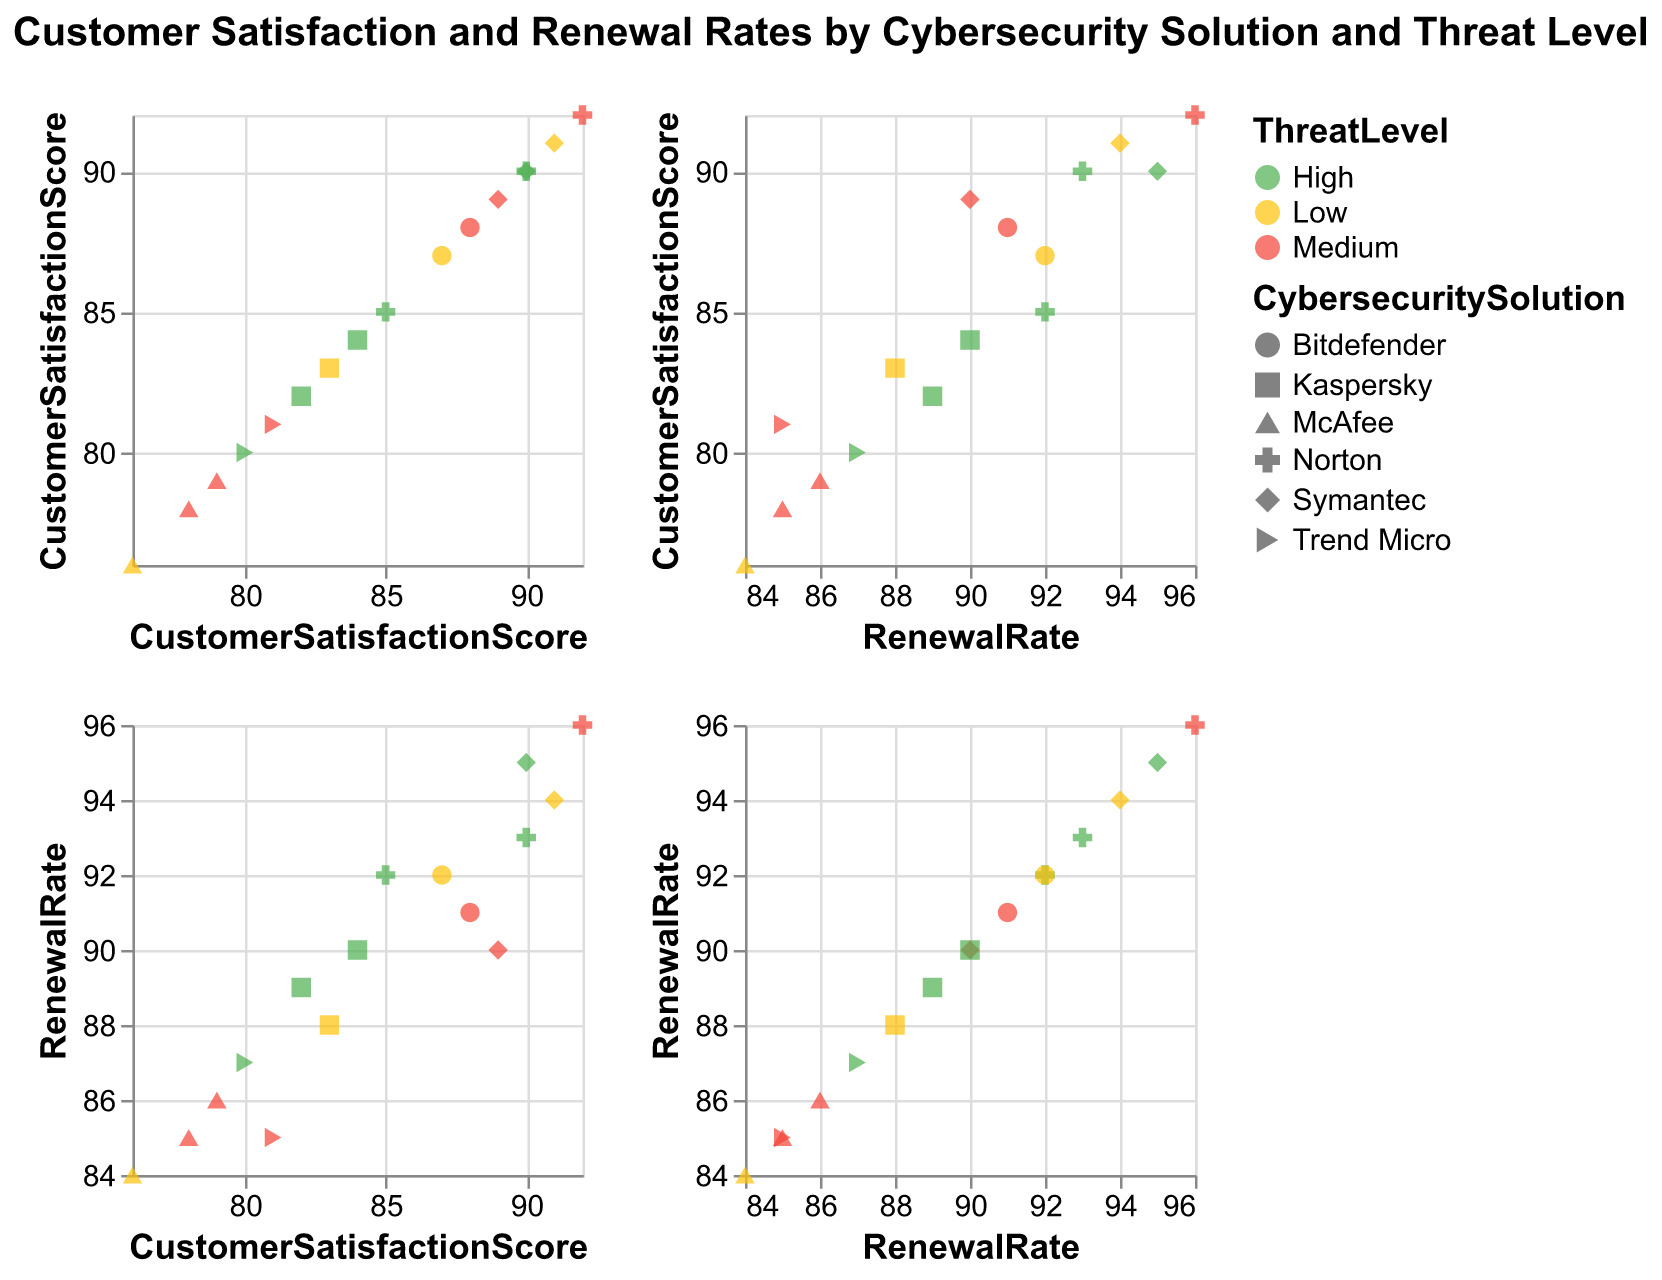What is the title of the scatter plot matrix? The title of the scatter plot matrix is typically found at the top of the figure, clearly indicating the focus of the data visualization. In this case, you can see it at the center and slightly above the matrix.
Answer: Customer Satisfaction and Renewal Rates by Cybersecurity Solution and Threat Level How many data points are there for the McAfee solution? You can determine the number of data points by looking for unique shapes corresponding to McAfee in the legend and counting them. In this matrix, McAfee is represented by a particular shape, visualized multiple times across different plots.
Answer: 3 Which threat level is associated with the highest customer satisfaction score? By examining the colors associated with the highest points on the Customer Satisfaction Score axis, you will see which color (and thus which threat level) corresponds to the highest score.
Answer: Medium Is there a noticeable trend between customer satisfaction scores and renewal rates? By observing the scatter plots where customer satisfaction scores are on one axis and renewal rates on the other, you can generally evaluate the relationship. Look at the clustering and direction of the points to infer a trend.
Answer: Yes, higher satisfaction scores generally relate to higher renewal rates Which cybersecurity solution shows the highest customer satisfaction score? Identify the shape corresponding to each cybersecurity solution in the legend and find which approach has the point with the highest value on the Customer Satisfaction Score axis.
Answer: Norton Between high and medium threat levels, which one has more data points with customer satisfaction scores above 90? Count the number of data points for high and medium threat levels (using their associated colors) that have customer satisfaction scores above 90 across the relevant plots.
Answer: High For which threat level is the difference between the highest and the lowest renewal rate the greatest? For each threat level (distinguished by color), determine the highest and lowest renewal rates from the scatter plots. Then, calculate the differences and compare them.
Answer: Medium How does the performance of Norton compare to Symantec in terms of customer satisfaction scores? Find the data points for Norton and Symantec by referring to their shapes in the legend. Compare the values of their customer satisfaction scores to identify patterns or differences.
Answer: Norton generally has slightly higher scores What’s the average renewal rate of Bitdefender solutions across different threat levels? Locate the points for Bitdefender, note their renewal rates, sum these rates, and then divide by the number of points (data entries) for Bitdefender.
Answer: 91.67 Which cybersecurity solution has the most consistent customer satisfaction score across different threat levels? Consistency can be judged by the spread of the data points. For each solution, check how tightly grouped the customer satisfaction scores are across threat levels.
Answer: Symantec 